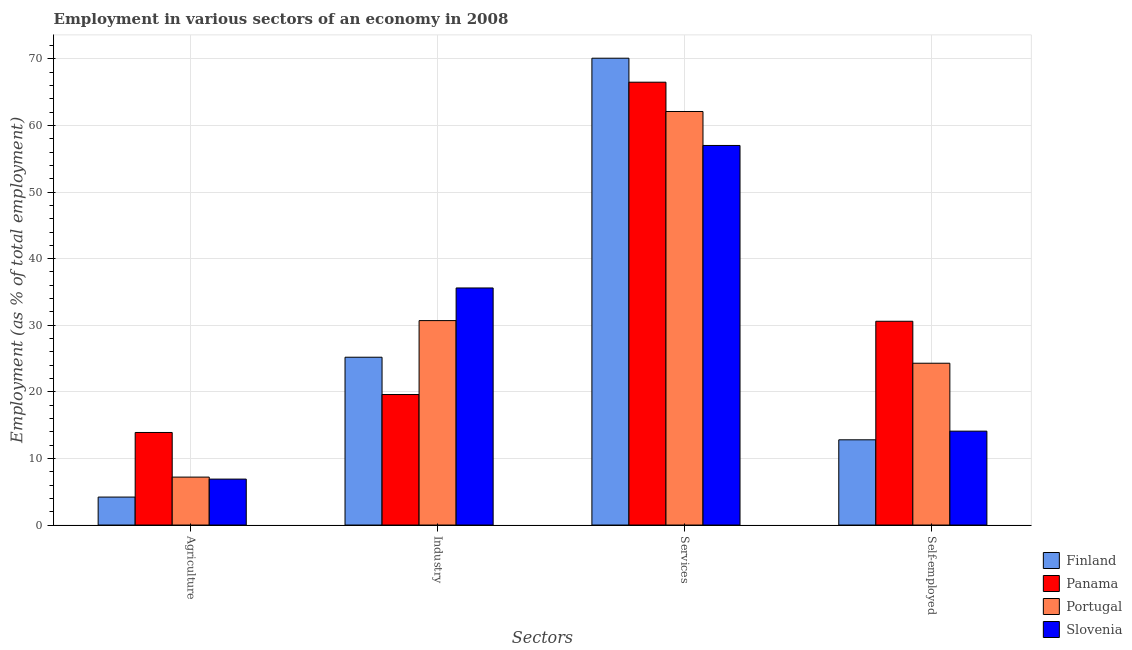How many different coloured bars are there?
Keep it short and to the point. 4. Are the number of bars on each tick of the X-axis equal?
Ensure brevity in your answer.  Yes. How many bars are there on the 2nd tick from the left?
Offer a terse response. 4. What is the label of the 4th group of bars from the left?
Offer a terse response. Self-employed. What is the percentage of self employed workers in Slovenia?
Provide a succinct answer. 14.1. Across all countries, what is the maximum percentage of workers in agriculture?
Provide a succinct answer. 13.9. Across all countries, what is the minimum percentage of workers in agriculture?
Your answer should be compact. 4.2. In which country was the percentage of workers in industry maximum?
Your answer should be compact. Slovenia. What is the total percentage of workers in agriculture in the graph?
Provide a succinct answer. 32.2. What is the difference between the percentage of workers in industry in Panama and that in Finland?
Ensure brevity in your answer.  -5.6. What is the difference between the percentage of self employed workers in Portugal and the percentage of workers in industry in Slovenia?
Keep it short and to the point. -11.3. What is the average percentage of workers in industry per country?
Your response must be concise. 27.78. What is the difference between the percentage of self employed workers and percentage of workers in industry in Panama?
Your response must be concise. 11. In how many countries, is the percentage of self employed workers greater than 22 %?
Ensure brevity in your answer.  2. What is the ratio of the percentage of workers in services in Portugal to that in Panama?
Keep it short and to the point. 0.93. What is the difference between the highest and the second highest percentage of self employed workers?
Offer a terse response. 6.3. What is the difference between the highest and the lowest percentage of workers in agriculture?
Ensure brevity in your answer.  9.7. In how many countries, is the percentage of workers in industry greater than the average percentage of workers in industry taken over all countries?
Offer a terse response. 2. Is the sum of the percentage of workers in services in Slovenia and Panama greater than the maximum percentage of workers in agriculture across all countries?
Make the answer very short. Yes. Is it the case that in every country, the sum of the percentage of workers in services and percentage of workers in agriculture is greater than the sum of percentage of self employed workers and percentage of workers in industry?
Give a very brief answer. No. What does the 1st bar from the right in Agriculture represents?
Offer a terse response. Slovenia. Is it the case that in every country, the sum of the percentage of workers in agriculture and percentage of workers in industry is greater than the percentage of workers in services?
Provide a short and direct response. No. How many bars are there?
Give a very brief answer. 16. Are all the bars in the graph horizontal?
Give a very brief answer. No. How many countries are there in the graph?
Ensure brevity in your answer.  4. What is the difference between two consecutive major ticks on the Y-axis?
Offer a terse response. 10. Does the graph contain any zero values?
Keep it short and to the point. No. Where does the legend appear in the graph?
Keep it short and to the point. Bottom right. How many legend labels are there?
Your answer should be compact. 4. How are the legend labels stacked?
Your answer should be compact. Vertical. What is the title of the graph?
Make the answer very short. Employment in various sectors of an economy in 2008. Does "India" appear as one of the legend labels in the graph?
Your answer should be compact. No. What is the label or title of the X-axis?
Make the answer very short. Sectors. What is the label or title of the Y-axis?
Provide a short and direct response. Employment (as % of total employment). What is the Employment (as % of total employment) in Finland in Agriculture?
Offer a very short reply. 4.2. What is the Employment (as % of total employment) of Panama in Agriculture?
Keep it short and to the point. 13.9. What is the Employment (as % of total employment) of Portugal in Agriculture?
Give a very brief answer. 7.2. What is the Employment (as % of total employment) of Slovenia in Agriculture?
Your answer should be compact. 6.9. What is the Employment (as % of total employment) in Finland in Industry?
Give a very brief answer. 25.2. What is the Employment (as % of total employment) in Panama in Industry?
Offer a very short reply. 19.6. What is the Employment (as % of total employment) of Portugal in Industry?
Give a very brief answer. 30.7. What is the Employment (as % of total employment) in Slovenia in Industry?
Ensure brevity in your answer.  35.6. What is the Employment (as % of total employment) in Finland in Services?
Keep it short and to the point. 70.1. What is the Employment (as % of total employment) of Panama in Services?
Make the answer very short. 66.5. What is the Employment (as % of total employment) in Portugal in Services?
Give a very brief answer. 62.1. What is the Employment (as % of total employment) of Slovenia in Services?
Make the answer very short. 57. What is the Employment (as % of total employment) of Finland in Self-employed?
Your answer should be compact. 12.8. What is the Employment (as % of total employment) in Panama in Self-employed?
Provide a short and direct response. 30.6. What is the Employment (as % of total employment) in Portugal in Self-employed?
Your answer should be compact. 24.3. What is the Employment (as % of total employment) of Slovenia in Self-employed?
Keep it short and to the point. 14.1. Across all Sectors, what is the maximum Employment (as % of total employment) in Finland?
Give a very brief answer. 70.1. Across all Sectors, what is the maximum Employment (as % of total employment) in Panama?
Your answer should be very brief. 66.5. Across all Sectors, what is the maximum Employment (as % of total employment) in Portugal?
Your response must be concise. 62.1. Across all Sectors, what is the minimum Employment (as % of total employment) of Finland?
Your answer should be very brief. 4.2. Across all Sectors, what is the minimum Employment (as % of total employment) of Panama?
Provide a succinct answer. 13.9. Across all Sectors, what is the minimum Employment (as % of total employment) of Portugal?
Your answer should be very brief. 7.2. Across all Sectors, what is the minimum Employment (as % of total employment) in Slovenia?
Offer a very short reply. 6.9. What is the total Employment (as % of total employment) of Finland in the graph?
Make the answer very short. 112.3. What is the total Employment (as % of total employment) in Panama in the graph?
Make the answer very short. 130.6. What is the total Employment (as % of total employment) in Portugal in the graph?
Give a very brief answer. 124.3. What is the total Employment (as % of total employment) in Slovenia in the graph?
Your response must be concise. 113.6. What is the difference between the Employment (as % of total employment) of Finland in Agriculture and that in Industry?
Provide a short and direct response. -21. What is the difference between the Employment (as % of total employment) of Portugal in Agriculture and that in Industry?
Your answer should be very brief. -23.5. What is the difference between the Employment (as % of total employment) in Slovenia in Agriculture and that in Industry?
Your answer should be compact. -28.7. What is the difference between the Employment (as % of total employment) in Finland in Agriculture and that in Services?
Ensure brevity in your answer.  -65.9. What is the difference between the Employment (as % of total employment) of Panama in Agriculture and that in Services?
Offer a terse response. -52.6. What is the difference between the Employment (as % of total employment) of Portugal in Agriculture and that in Services?
Your answer should be compact. -54.9. What is the difference between the Employment (as % of total employment) in Slovenia in Agriculture and that in Services?
Your answer should be very brief. -50.1. What is the difference between the Employment (as % of total employment) of Panama in Agriculture and that in Self-employed?
Give a very brief answer. -16.7. What is the difference between the Employment (as % of total employment) in Portugal in Agriculture and that in Self-employed?
Your response must be concise. -17.1. What is the difference between the Employment (as % of total employment) of Slovenia in Agriculture and that in Self-employed?
Your answer should be very brief. -7.2. What is the difference between the Employment (as % of total employment) of Finland in Industry and that in Services?
Make the answer very short. -44.9. What is the difference between the Employment (as % of total employment) in Panama in Industry and that in Services?
Give a very brief answer. -46.9. What is the difference between the Employment (as % of total employment) of Portugal in Industry and that in Services?
Give a very brief answer. -31.4. What is the difference between the Employment (as % of total employment) in Slovenia in Industry and that in Services?
Make the answer very short. -21.4. What is the difference between the Employment (as % of total employment) in Finland in Industry and that in Self-employed?
Give a very brief answer. 12.4. What is the difference between the Employment (as % of total employment) in Panama in Industry and that in Self-employed?
Your response must be concise. -11. What is the difference between the Employment (as % of total employment) of Portugal in Industry and that in Self-employed?
Offer a very short reply. 6.4. What is the difference between the Employment (as % of total employment) in Slovenia in Industry and that in Self-employed?
Keep it short and to the point. 21.5. What is the difference between the Employment (as % of total employment) in Finland in Services and that in Self-employed?
Make the answer very short. 57.3. What is the difference between the Employment (as % of total employment) of Panama in Services and that in Self-employed?
Make the answer very short. 35.9. What is the difference between the Employment (as % of total employment) in Portugal in Services and that in Self-employed?
Keep it short and to the point. 37.8. What is the difference between the Employment (as % of total employment) in Slovenia in Services and that in Self-employed?
Make the answer very short. 42.9. What is the difference between the Employment (as % of total employment) of Finland in Agriculture and the Employment (as % of total employment) of Panama in Industry?
Offer a very short reply. -15.4. What is the difference between the Employment (as % of total employment) of Finland in Agriculture and the Employment (as % of total employment) of Portugal in Industry?
Give a very brief answer. -26.5. What is the difference between the Employment (as % of total employment) of Finland in Agriculture and the Employment (as % of total employment) of Slovenia in Industry?
Ensure brevity in your answer.  -31.4. What is the difference between the Employment (as % of total employment) in Panama in Agriculture and the Employment (as % of total employment) in Portugal in Industry?
Give a very brief answer. -16.8. What is the difference between the Employment (as % of total employment) in Panama in Agriculture and the Employment (as % of total employment) in Slovenia in Industry?
Your answer should be compact. -21.7. What is the difference between the Employment (as % of total employment) in Portugal in Agriculture and the Employment (as % of total employment) in Slovenia in Industry?
Keep it short and to the point. -28.4. What is the difference between the Employment (as % of total employment) of Finland in Agriculture and the Employment (as % of total employment) of Panama in Services?
Provide a short and direct response. -62.3. What is the difference between the Employment (as % of total employment) of Finland in Agriculture and the Employment (as % of total employment) of Portugal in Services?
Ensure brevity in your answer.  -57.9. What is the difference between the Employment (as % of total employment) of Finland in Agriculture and the Employment (as % of total employment) of Slovenia in Services?
Your answer should be very brief. -52.8. What is the difference between the Employment (as % of total employment) of Panama in Agriculture and the Employment (as % of total employment) of Portugal in Services?
Give a very brief answer. -48.2. What is the difference between the Employment (as % of total employment) in Panama in Agriculture and the Employment (as % of total employment) in Slovenia in Services?
Keep it short and to the point. -43.1. What is the difference between the Employment (as % of total employment) in Portugal in Agriculture and the Employment (as % of total employment) in Slovenia in Services?
Provide a short and direct response. -49.8. What is the difference between the Employment (as % of total employment) of Finland in Agriculture and the Employment (as % of total employment) of Panama in Self-employed?
Provide a short and direct response. -26.4. What is the difference between the Employment (as % of total employment) of Finland in Agriculture and the Employment (as % of total employment) of Portugal in Self-employed?
Ensure brevity in your answer.  -20.1. What is the difference between the Employment (as % of total employment) of Panama in Agriculture and the Employment (as % of total employment) of Slovenia in Self-employed?
Your answer should be very brief. -0.2. What is the difference between the Employment (as % of total employment) of Portugal in Agriculture and the Employment (as % of total employment) of Slovenia in Self-employed?
Offer a terse response. -6.9. What is the difference between the Employment (as % of total employment) of Finland in Industry and the Employment (as % of total employment) of Panama in Services?
Offer a terse response. -41.3. What is the difference between the Employment (as % of total employment) of Finland in Industry and the Employment (as % of total employment) of Portugal in Services?
Your response must be concise. -36.9. What is the difference between the Employment (as % of total employment) in Finland in Industry and the Employment (as % of total employment) in Slovenia in Services?
Offer a very short reply. -31.8. What is the difference between the Employment (as % of total employment) in Panama in Industry and the Employment (as % of total employment) in Portugal in Services?
Offer a terse response. -42.5. What is the difference between the Employment (as % of total employment) in Panama in Industry and the Employment (as % of total employment) in Slovenia in Services?
Make the answer very short. -37.4. What is the difference between the Employment (as % of total employment) in Portugal in Industry and the Employment (as % of total employment) in Slovenia in Services?
Offer a very short reply. -26.3. What is the difference between the Employment (as % of total employment) in Finland in Industry and the Employment (as % of total employment) in Panama in Self-employed?
Give a very brief answer. -5.4. What is the difference between the Employment (as % of total employment) of Finland in Industry and the Employment (as % of total employment) of Slovenia in Self-employed?
Keep it short and to the point. 11.1. What is the difference between the Employment (as % of total employment) in Finland in Services and the Employment (as % of total employment) in Panama in Self-employed?
Ensure brevity in your answer.  39.5. What is the difference between the Employment (as % of total employment) in Finland in Services and the Employment (as % of total employment) in Portugal in Self-employed?
Provide a short and direct response. 45.8. What is the difference between the Employment (as % of total employment) in Panama in Services and the Employment (as % of total employment) in Portugal in Self-employed?
Offer a terse response. 42.2. What is the difference between the Employment (as % of total employment) of Panama in Services and the Employment (as % of total employment) of Slovenia in Self-employed?
Make the answer very short. 52.4. What is the average Employment (as % of total employment) in Finland per Sectors?
Make the answer very short. 28.07. What is the average Employment (as % of total employment) of Panama per Sectors?
Provide a short and direct response. 32.65. What is the average Employment (as % of total employment) of Portugal per Sectors?
Offer a very short reply. 31.07. What is the average Employment (as % of total employment) in Slovenia per Sectors?
Offer a terse response. 28.4. What is the difference between the Employment (as % of total employment) of Finland and Employment (as % of total employment) of Panama in Agriculture?
Give a very brief answer. -9.7. What is the difference between the Employment (as % of total employment) of Finland and Employment (as % of total employment) of Slovenia in Agriculture?
Provide a short and direct response. -2.7. What is the difference between the Employment (as % of total employment) of Finland and Employment (as % of total employment) of Panama in Industry?
Offer a very short reply. 5.6. What is the difference between the Employment (as % of total employment) in Finland and Employment (as % of total employment) in Slovenia in Industry?
Provide a short and direct response. -10.4. What is the difference between the Employment (as % of total employment) in Panama and Employment (as % of total employment) in Slovenia in Industry?
Offer a very short reply. -16. What is the difference between the Employment (as % of total employment) in Finland and Employment (as % of total employment) in Panama in Services?
Provide a succinct answer. 3.6. What is the difference between the Employment (as % of total employment) of Panama and Employment (as % of total employment) of Portugal in Services?
Keep it short and to the point. 4.4. What is the difference between the Employment (as % of total employment) in Portugal and Employment (as % of total employment) in Slovenia in Services?
Keep it short and to the point. 5.1. What is the difference between the Employment (as % of total employment) in Finland and Employment (as % of total employment) in Panama in Self-employed?
Offer a terse response. -17.8. What is the difference between the Employment (as % of total employment) of Panama and Employment (as % of total employment) of Portugal in Self-employed?
Give a very brief answer. 6.3. What is the difference between the Employment (as % of total employment) of Panama and Employment (as % of total employment) of Slovenia in Self-employed?
Make the answer very short. 16.5. What is the difference between the Employment (as % of total employment) of Portugal and Employment (as % of total employment) of Slovenia in Self-employed?
Your answer should be very brief. 10.2. What is the ratio of the Employment (as % of total employment) in Finland in Agriculture to that in Industry?
Provide a short and direct response. 0.17. What is the ratio of the Employment (as % of total employment) in Panama in Agriculture to that in Industry?
Provide a succinct answer. 0.71. What is the ratio of the Employment (as % of total employment) in Portugal in Agriculture to that in Industry?
Provide a short and direct response. 0.23. What is the ratio of the Employment (as % of total employment) in Slovenia in Agriculture to that in Industry?
Make the answer very short. 0.19. What is the ratio of the Employment (as % of total employment) of Finland in Agriculture to that in Services?
Provide a short and direct response. 0.06. What is the ratio of the Employment (as % of total employment) of Panama in Agriculture to that in Services?
Ensure brevity in your answer.  0.21. What is the ratio of the Employment (as % of total employment) of Portugal in Agriculture to that in Services?
Your answer should be very brief. 0.12. What is the ratio of the Employment (as % of total employment) of Slovenia in Agriculture to that in Services?
Your response must be concise. 0.12. What is the ratio of the Employment (as % of total employment) of Finland in Agriculture to that in Self-employed?
Keep it short and to the point. 0.33. What is the ratio of the Employment (as % of total employment) in Panama in Agriculture to that in Self-employed?
Ensure brevity in your answer.  0.45. What is the ratio of the Employment (as % of total employment) in Portugal in Agriculture to that in Self-employed?
Your response must be concise. 0.3. What is the ratio of the Employment (as % of total employment) of Slovenia in Agriculture to that in Self-employed?
Your answer should be very brief. 0.49. What is the ratio of the Employment (as % of total employment) of Finland in Industry to that in Services?
Give a very brief answer. 0.36. What is the ratio of the Employment (as % of total employment) of Panama in Industry to that in Services?
Provide a succinct answer. 0.29. What is the ratio of the Employment (as % of total employment) in Portugal in Industry to that in Services?
Your answer should be very brief. 0.49. What is the ratio of the Employment (as % of total employment) of Slovenia in Industry to that in Services?
Provide a succinct answer. 0.62. What is the ratio of the Employment (as % of total employment) of Finland in Industry to that in Self-employed?
Ensure brevity in your answer.  1.97. What is the ratio of the Employment (as % of total employment) in Panama in Industry to that in Self-employed?
Offer a terse response. 0.64. What is the ratio of the Employment (as % of total employment) in Portugal in Industry to that in Self-employed?
Give a very brief answer. 1.26. What is the ratio of the Employment (as % of total employment) in Slovenia in Industry to that in Self-employed?
Offer a very short reply. 2.52. What is the ratio of the Employment (as % of total employment) of Finland in Services to that in Self-employed?
Offer a very short reply. 5.48. What is the ratio of the Employment (as % of total employment) in Panama in Services to that in Self-employed?
Ensure brevity in your answer.  2.17. What is the ratio of the Employment (as % of total employment) of Portugal in Services to that in Self-employed?
Offer a terse response. 2.56. What is the ratio of the Employment (as % of total employment) in Slovenia in Services to that in Self-employed?
Provide a short and direct response. 4.04. What is the difference between the highest and the second highest Employment (as % of total employment) of Finland?
Keep it short and to the point. 44.9. What is the difference between the highest and the second highest Employment (as % of total employment) of Panama?
Your answer should be compact. 35.9. What is the difference between the highest and the second highest Employment (as % of total employment) of Portugal?
Offer a terse response. 31.4. What is the difference between the highest and the second highest Employment (as % of total employment) of Slovenia?
Your answer should be very brief. 21.4. What is the difference between the highest and the lowest Employment (as % of total employment) in Finland?
Provide a succinct answer. 65.9. What is the difference between the highest and the lowest Employment (as % of total employment) in Panama?
Provide a short and direct response. 52.6. What is the difference between the highest and the lowest Employment (as % of total employment) of Portugal?
Give a very brief answer. 54.9. What is the difference between the highest and the lowest Employment (as % of total employment) in Slovenia?
Ensure brevity in your answer.  50.1. 